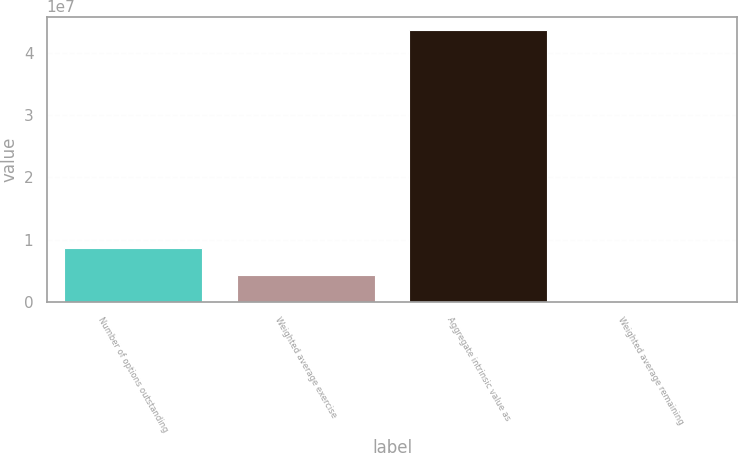Convert chart to OTSL. <chart><loc_0><loc_0><loc_500><loc_500><bar_chart><fcel>Number of options outstanding<fcel>Weighted average exercise<fcel>Aggregate intrinsic value as<fcel>Weighted average remaining<nl><fcel>8.71883e+06<fcel>4.35942e+06<fcel>4.35942e+07<fcel>1.4<nl></chart> 